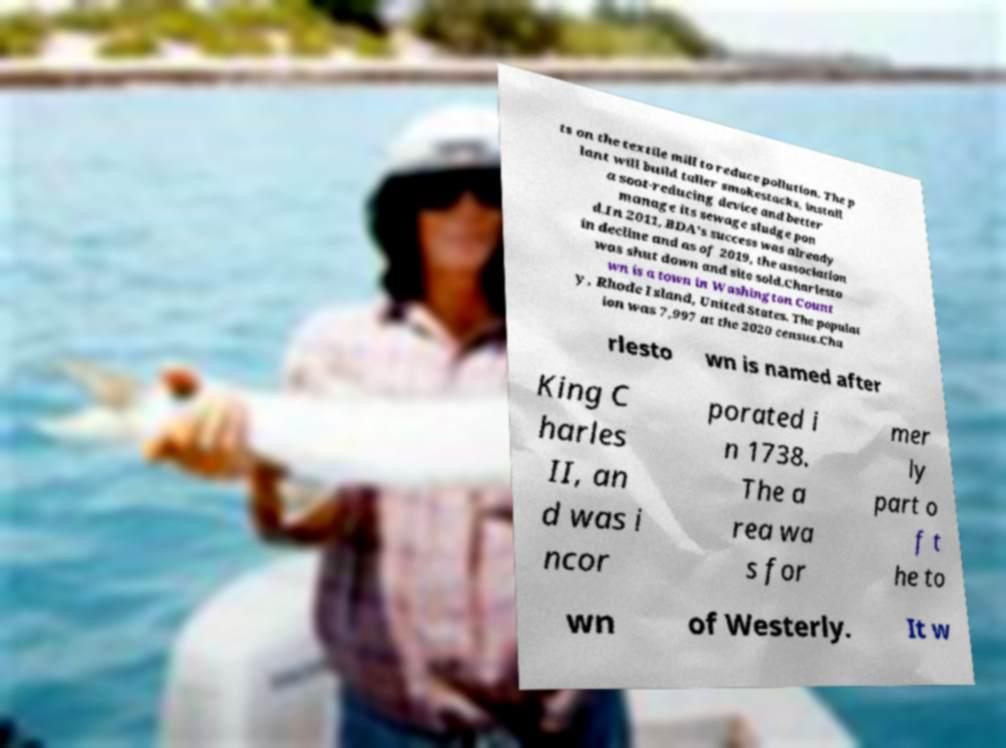Can you read and provide the text displayed in the image?This photo seems to have some interesting text. Can you extract and type it out for me? ts on the textile mill to reduce pollution. The p lant will build taller smokestacks, install a soot-reducing device and better manage its sewage sludge pon d.In 2011, BDA's success was already in decline and as of 2019, the association was shut down and site sold.Charlesto wn is a town in Washington Count y, Rhode Island, United States. The populat ion was 7,997 at the 2020 census.Cha rlesto wn is named after King C harles II, an d was i ncor porated i n 1738. The a rea wa s for mer ly part o f t he to wn of Westerly. It w 